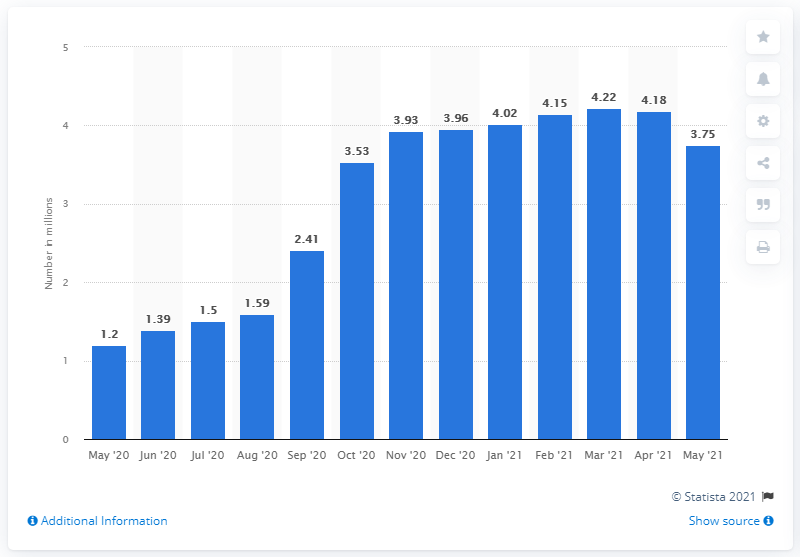Outline some significant characteristics in this image. As of May 2021, the number of long-term unemployed individuals in the United States was 3.75 million. 